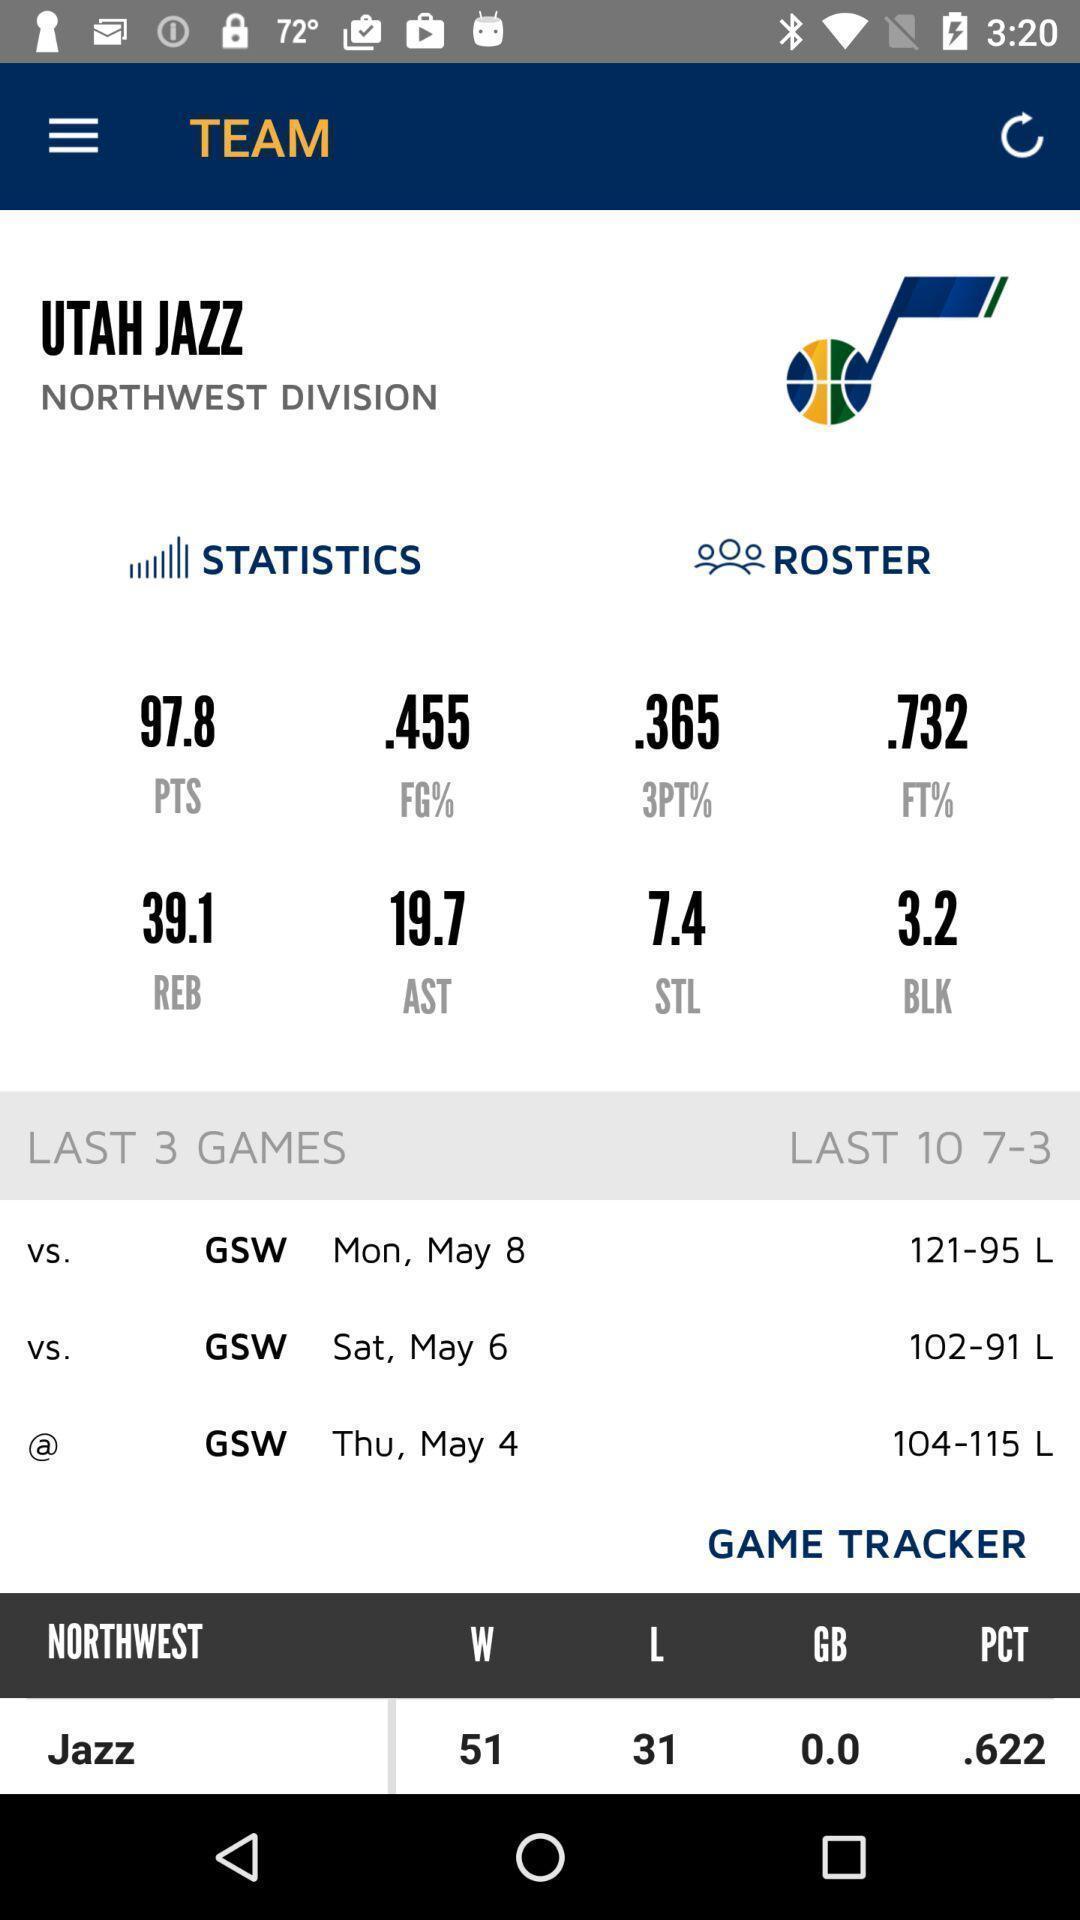Provide a detailed account of this screenshot. Score statistic page for a sports stand app. 